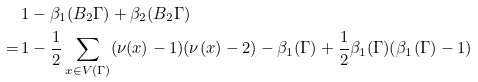<formula> <loc_0><loc_0><loc_500><loc_500>& \, 1 - \beta _ { 1 } ( B _ { 2 } \Gamma ) + \beta _ { 2 } ( B _ { 2 } \Gamma ) \\ = & \, 1 - \frac { 1 } { 2 } \sum _ { x \in V ( \Gamma ) } ( \nu ( x ) - 1 ) ( \nu ( x ) - 2 ) - \beta _ { 1 } ( \Gamma ) + \frac { 1 } { 2 } \beta _ { 1 } ( \Gamma ) ( \beta _ { 1 } ( \Gamma ) - 1 )</formula> 